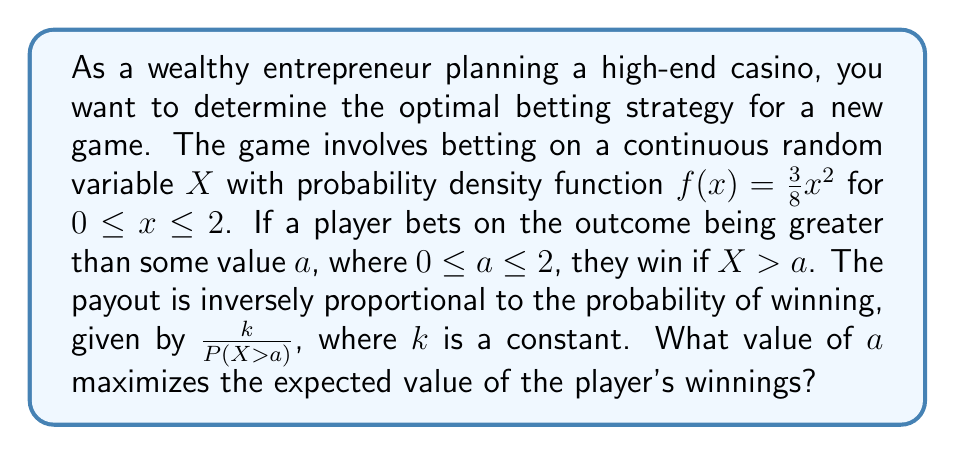Provide a solution to this math problem. Let's approach this step-by-step:

1) First, we need to find the probability of winning, $P(X > a)$:

   $$P(X > a) = \int_a^2 f(x) dx = \int_a^2 \frac{3}{8}x^2 dx$$

2) Evaluating this integral:

   $$P(X > a) = [\frac{1}{8}x^3]_a^2 = \frac{1}{8}(8 - a^3) = 1 - \frac{a^3}{8}$$

3) The payout when winning is $\frac{k}{P(X > a)} = \frac{k}{1 - \frac{a^3}{8}}$

4) The expected value of winnings, E(W), is the product of the probability of winning and the payout:

   $$E(W) = P(X > a) \cdot \frac{k}{P(X > a)} = k$$

5) This might seem counterintuitive, but it means that the expected value is constant regardless of the choice of $a$. However, we're looking for the optimal strategy, which in this case means minimizing risk.

6) To minimize risk, we want to maximize the probability of winning while maintaining the same expected value. This occurs when $a$ is at its minimum possible value, which is 0.

7) When $a = 0$, $P(X > a) = 1$, which means the player always wins, but with the minimum possible payout of $k$.

Therefore, the optimal betting strategy is to always bet on $X > 0$, which guarantees winning with the minimum payout, thus minimizing risk while maintaining the same expected value.
Answer: $a = 0$ 